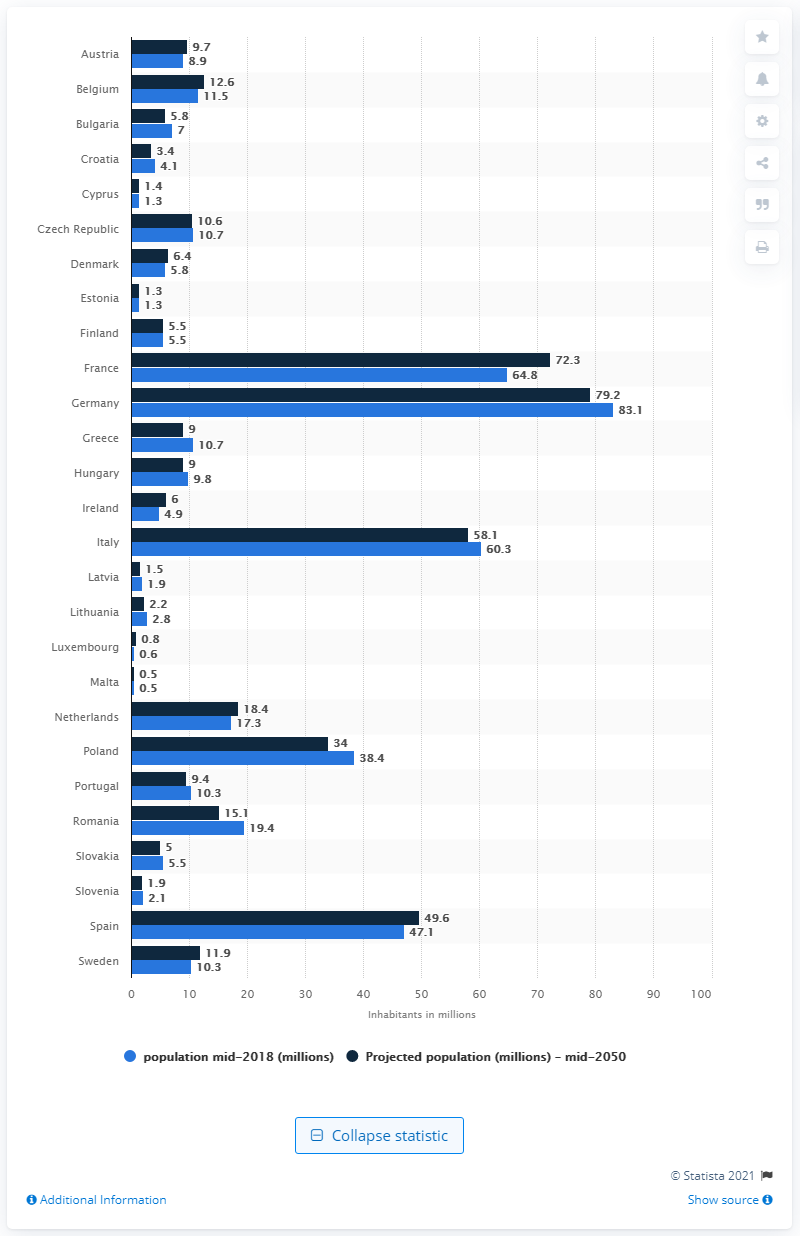Mention a couple of crucial points in this snapshot. It is projected that in 2050, the number of people living in Germany will be approximately 79.2 million. In 2019, Germany was the leading EU country in terms of population. 